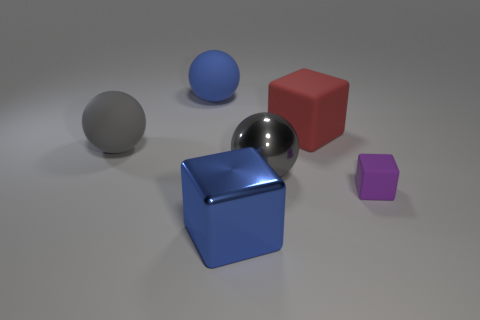What is the material of the large blue object that is the same shape as the small purple thing?
Your answer should be compact. Metal. What number of big objects are either red objects or blue spheres?
Make the answer very short. 2. Are there fewer red rubber things in front of the big blue block than red things that are behind the red rubber thing?
Keep it short and to the point. No. What number of objects are big blue rubber objects or red metallic cylinders?
Ensure brevity in your answer.  1. There is a blue cube; how many big blue objects are to the left of it?
Make the answer very short. 1. There is a purple thing that is the same material as the large blue sphere; what is its shape?
Your answer should be compact. Cube. Do the gray object that is right of the large blue matte ball and the blue rubber thing have the same shape?
Your answer should be compact. Yes. What number of brown things are cubes or shiny cubes?
Make the answer very short. 0. Are there the same number of objects left of the large gray shiny ball and large gray matte things that are to the right of the blue cube?
Ensure brevity in your answer.  No. What is the color of the block that is on the left side of the big cube that is on the right side of the big shiny object in front of the tiny cube?
Give a very brief answer. Blue. 